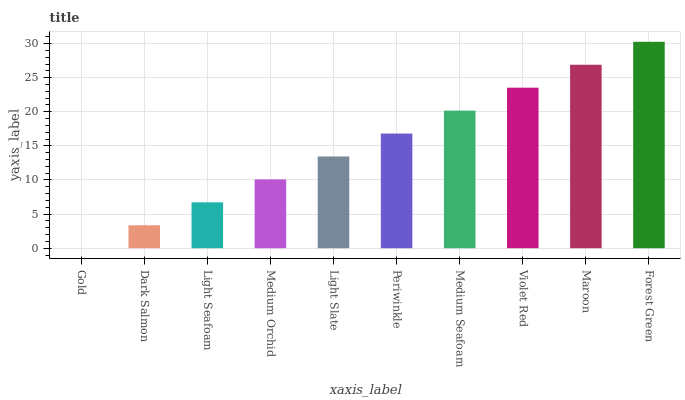Is Gold the minimum?
Answer yes or no. Yes. Is Forest Green the maximum?
Answer yes or no. Yes. Is Dark Salmon the minimum?
Answer yes or no. No. Is Dark Salmon the maximum?
Answer yes or no. No. Is Dark Salmon greater than Gold?
Answer yes or no. Yes. Is Gold less than Dark Salmon?
Answer yes or no. Yes. Is Gold greater than Dark Salmon?
Answer yes or no. No. Is Dark Salmon less than Gold?
Answer yes or no. No. Is Periwinkle the high median?
Answer yes or no. Yes. Is Light Slate the low median?
Answer yes or no. Yes. Is Gold the high median?
Answer yes or no. No. Is Periwinkle the low median?
Answer yes or no. No. 